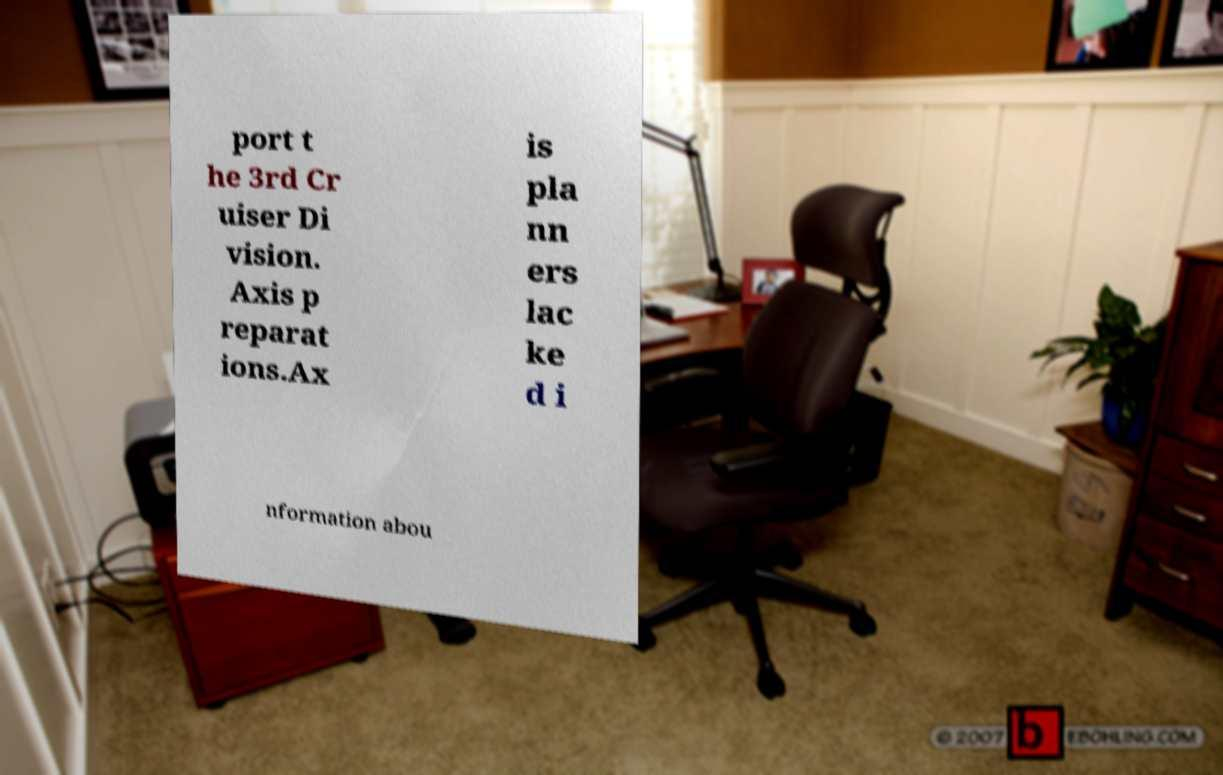Please identify and transcribe the text found in this image. port t he 3rd Cr uiser Di vision. Axis p reparat ions.Ax is pla nn ers lac ke d i nformation abou 